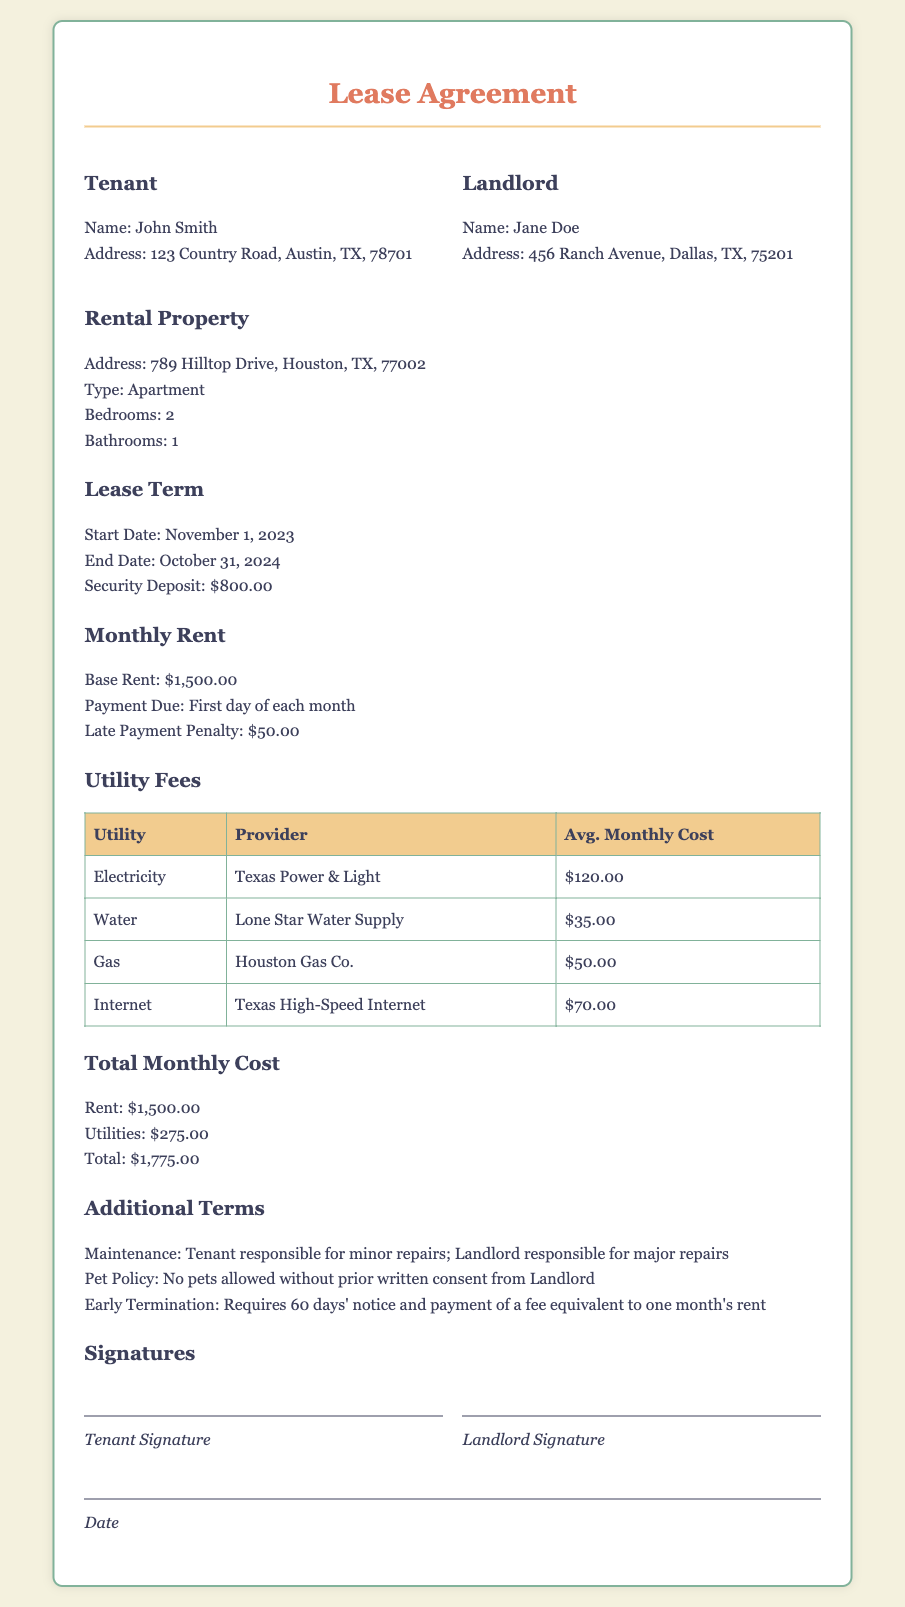What is the base rent? The base rent is specified in the Monthly Rent section of the document as $1,500.00.
Answer: $1,500.00 Who is the landlord? The landlord's name is mentioned in the document under the Landlord section, which is Jane Doe.
Answer: Jane Doe What is the average monthly cost of electricity? The average monthly cost for electricity is found in the Utility Fees table, indicating $120.00.
Answer: $120.00 What is the total monthly cost? The total monthly cost is calculated by adding the rent and utilities stated in the Total Monthly Cost section, which is $1,775.00.
Answer: $1,775.00 What is the late payment penalty? The document specifies that the late payment penalty is $50.00 under the Monthly Rent section.
Answer: $50.00 What is the security deposit amount? The security deposit is listed in the Lease Term section and is $800.00.
Answer: $800.00 How many bedrooms does the rental property have? The number of bedrooms is specified in the Rental Property section of the document, which states 2.
Answer: 2 What is the notice period for early termination? The notice period for early termination is mentioned in the Additional Terms section as 60 days.
Answer: 60 days Who is responsible for major repairs? The responsibility for major repairs is outlined in the Additional Terms section, indicating that the landlord is responsible.
Answer: Landlord 